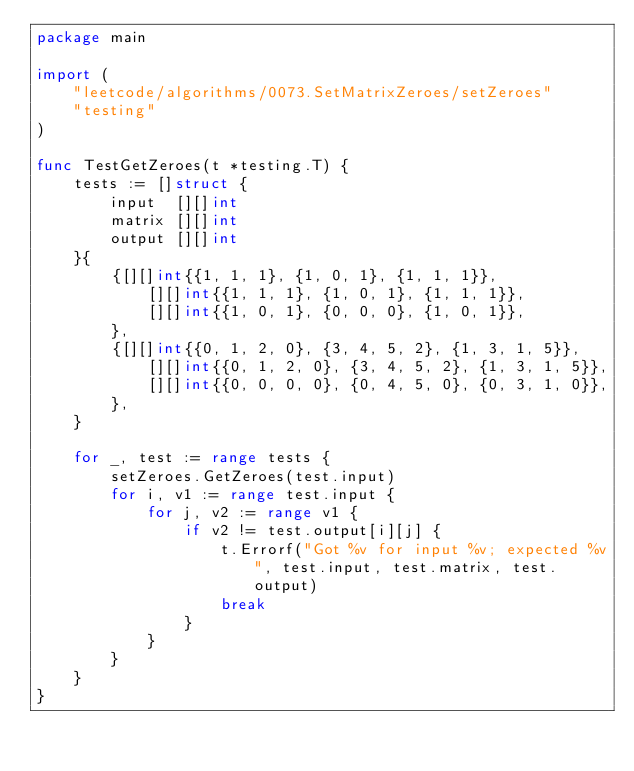Convert code to text. <code><loc_0><loc_0><loc_500><loc_500><_Go_>package main

import (
	"leetcode/algorithms/0073.SetMatrixZeroes/setZeroes"
	"testing"
)

func TestGetZeroes(t *testing.T) {
	tests := []struct {
		input  [][]int
		matrix [][]int
		output [][]int
	}{
		{[][]int{{1, 1, 1}, {1, 0, 1}, {1, 1, 1}},
			[][]int{{1, 1, 1}, {1, 0, 1}, {1, 1, 1}},
			[][]int{{1, 0, 1}, {0, 0, 0}, {1, 0, 1}},
		},
		{[][]int{{0, 1, 2, 0}, {3, 4, 5, 2}, {1, 3, 1, 5}},
			[][]int{{0, 1, 2, 0}, {3, 4, 5, 2}, {1, 3, 1, 5}},
			[][]int{{0, 0, 0, 0}, {0, 4, 5, 0}, {0, 3, 1, 0}},
		},
	}

	for _, test := range tests {
		setZeroes.GetZeroes(test.input)
		for i, v1 := range test.input {
			for j, v2 := range v1 {
				if v2 != test.output[i][j] {
					t.Errorf("Got %v for input %v; expected %v", test.input, test.matrix, test.output)
					break
				}
			}
		}
	}
}
</code> 